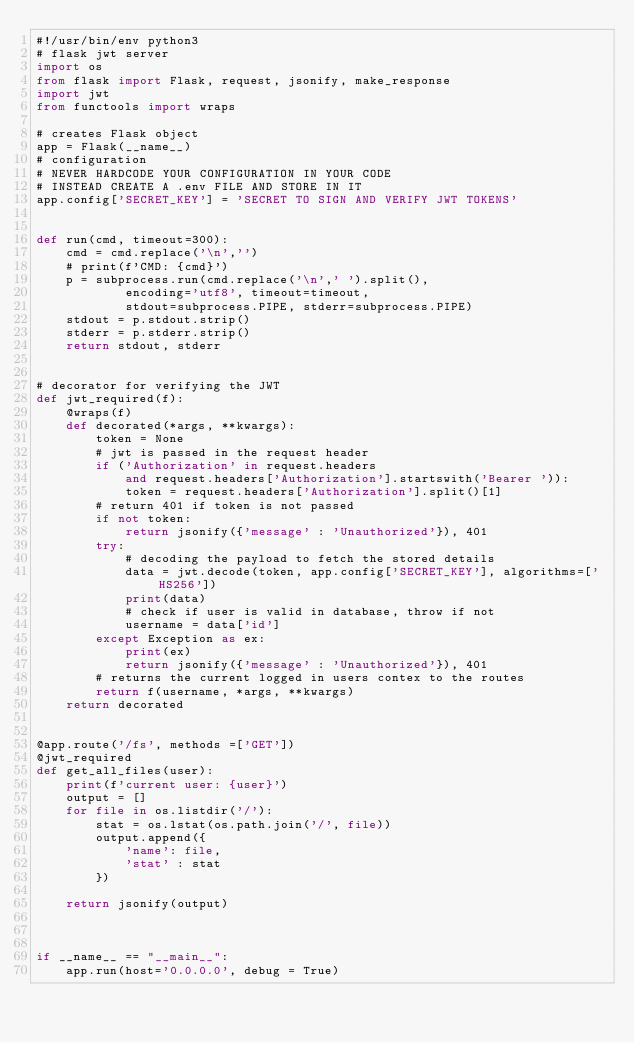<code> <loc_0><loc_0><loc_500><loc_500><_Python_>#!/usr/bin/env python3
# flask jwt server
import os
from flask import Flask, request, jsonify, make_response
import jwt
from functools import wraps

# creates Flask object
app = Flask(__name__)
# configuration
# NEVER HARDCODE YOUR CONFIGURATION IN YOUR CODE
# INSTEAD CREATE A .env FILE AND STORE IN IT
app.config['SECRET_KEY'] = 'SECRET TO SIGN AND VERIFY JWT TOKENS'


def run(cmd, timeout=300):
	cmd = cmd.replace('\n','')
	# print(f'CMD: {cmd}')
	p = subprocess.run(cmd.replace('\n',' ').split(), 
			encoding='utf8', timeout=timeout, 
			stdout=subprocess.PIPE, stderr=subprocess.PIPE)
	stdout = p.stdout.strip()
	stderr = p.stderr.strip()
	return stdout, stderr


# decorator for verifying the JWT
def jwt_required(f):
	@wraps(f)
	def decorated(*args, **kwargs):
		token = None
		# jwt is passed in the request header
		if ('Authorization' in request.headers 
			and request.headers['Authorization'].startswith('Bearer ')):
			token = request.headers['Authorization'].split()[1]
		# return 401 if token is not passed
		if not token:
			return jsonify({'message' : 'Unauthorized'}), 401
		try:
			# decoding the payload to fetch the stored details
			data = jwt.decode(token, app.config['SECRET_KEY'], algorithms=['HS256'])
			print(data)
			# check if user is valid in database, throw if not 
			username = data['id']
		except Exception as ex:
			print(ex)
			return jsonify({'message' : 'Unauthorized'}), 401
		# returns the current logged in users contex to the routes
		return f(username, *args, **kwargs)
	return decorated


@app.route('/fs', methods =['GET'])
@jwt_required
def get_all_files(user):
	print(f'current user: {user}')
	output = []
	for file in os.listdir('/'):
		stat = os.lstat(os.path.join('/', file))
		output.append({
			'name': file,
			'stat' : stat
		})

	return jsonify(output)



if __name__ == "__main__":
	app.run(host='0.0.0.0', debug = True)
</code> 